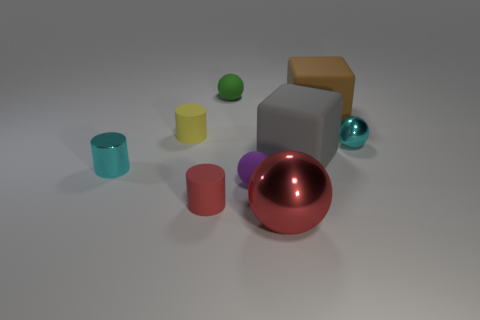Which objects in the image have similar shapes? The two cylinders in the image share a similar shape with their round bases and equal height. However, they are distinct in color, one being cyan and the other lime green. Are there any other objects that resemble each other in shape? Yes, the sphere and the smaller sphere-like object to its right show both similarities and differences. They are both round, but they differ in size and texture. The larger sphere has a polished metallic look, while the smaller one appears to have a softer, matte finish. 